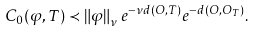<formula> <loc_0><loc_0><loc_500><loc_500>C _ { 0 } ( \varphi , T ) \prec \left \| \varphi \right \| _ { \nu } e ^ { - \nu d ( O , T ) } e ^ { - d ( O , O _ { T } ) } .</formula> 